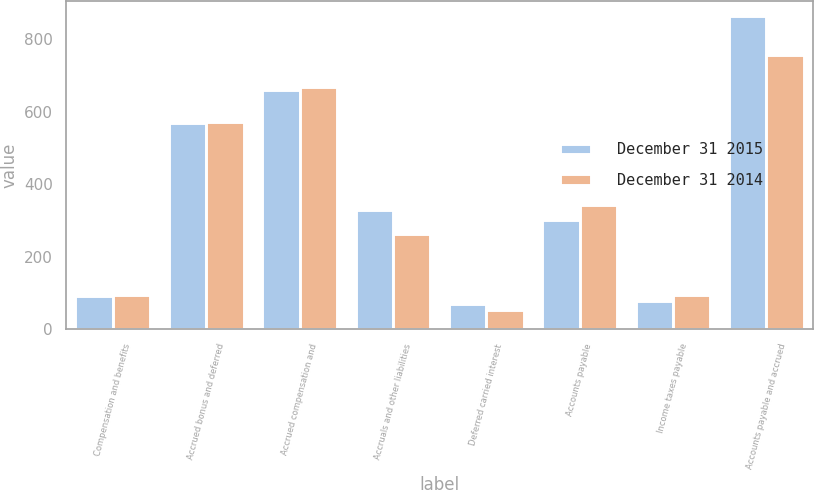Convert chart. <chart><loc_0><loc_0><loc_500><loc_500><stacked_bar_chart><ecel><fcel>Compensation and benefits<fcel>Accrued bonus and deferred<fcel>Accrued compensation and<fcel>Accruals and other liabilities<fcel>Deferred carried interest<fcel>Accounts payable<fcel>Income taxes payable<fcel>Accounts payable and accrued<nl><fcel>December 31 2015<fcel>93.2<fcel>568.1<fcel>661.3<fcel>328.6<fcel>69.2<fcel>302.6<fcel>78.8<fcel>863.1<nl><fcel>December 31 2014<fcel>94.4<fcel>572.9<fcel>667.3<fcel>263.8<fcel>54.8<fcel>343.5<fcel>95.2<fcel>757.3<nl></chart> 